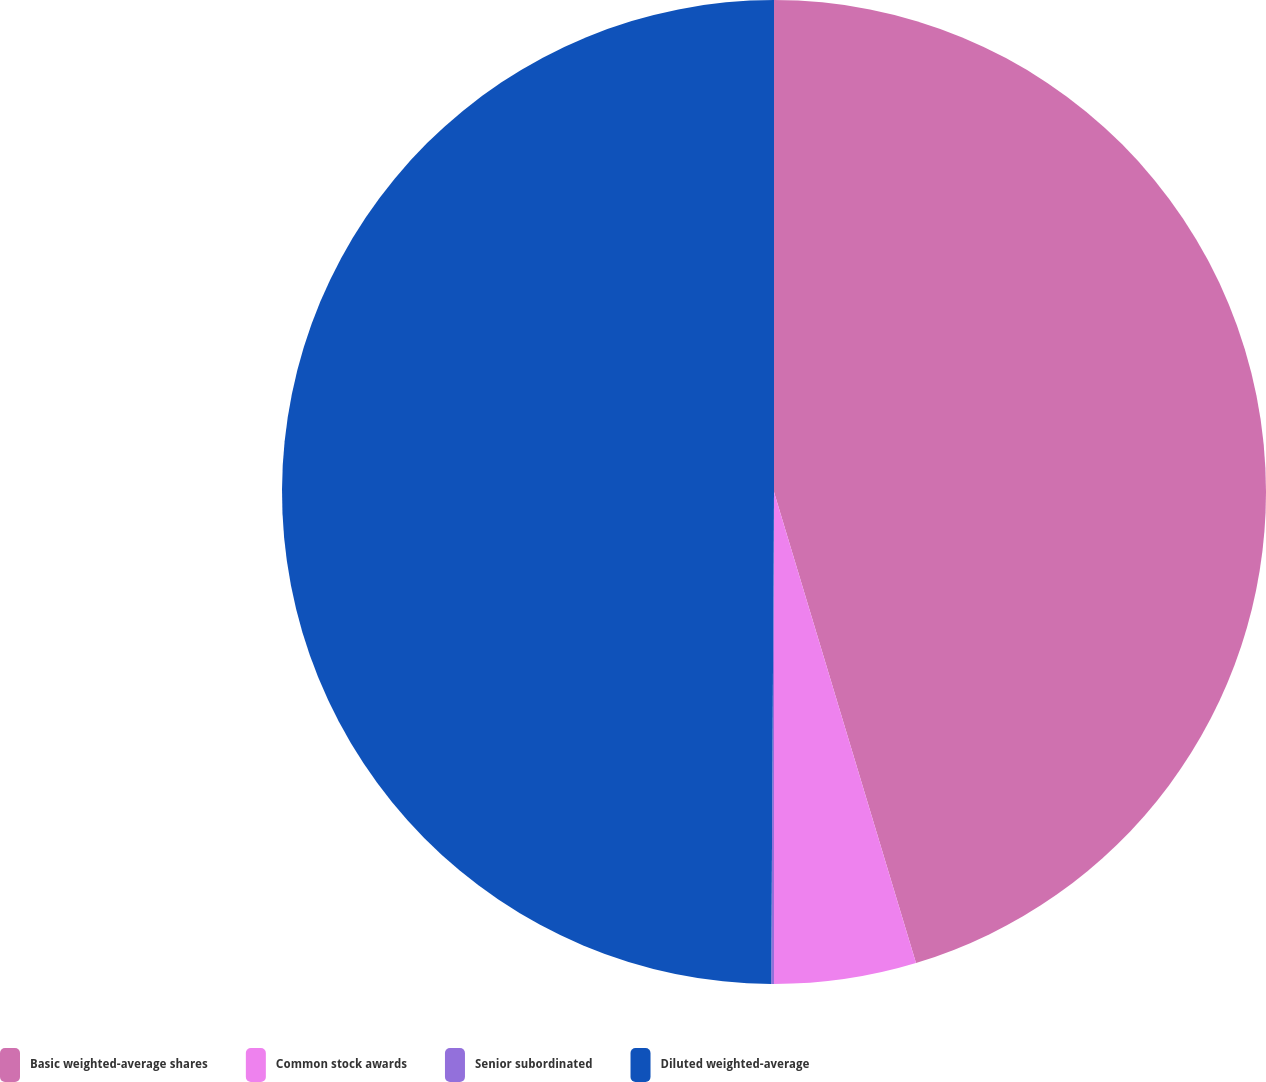Convert chart. <chart><loc_0><loc_0><loc_500><loc_500><pie_chart><fcel>Basic weighted-average shares<fcel>Common stock awards<fcel>Senior subordinated<fcel>Diluted weighted-average<nl><fcel>45.34%<fcel>4.66%<fcel>0.09%<fcel>49.91%<nl></chart> 